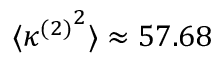<formula> <loc_0><loc_0><loc_500><loc_500>\langle { \kappa ^ { ( 2 ) } } ^ { 2 } \rangle \approx 5 7 . 6 8</formula> 